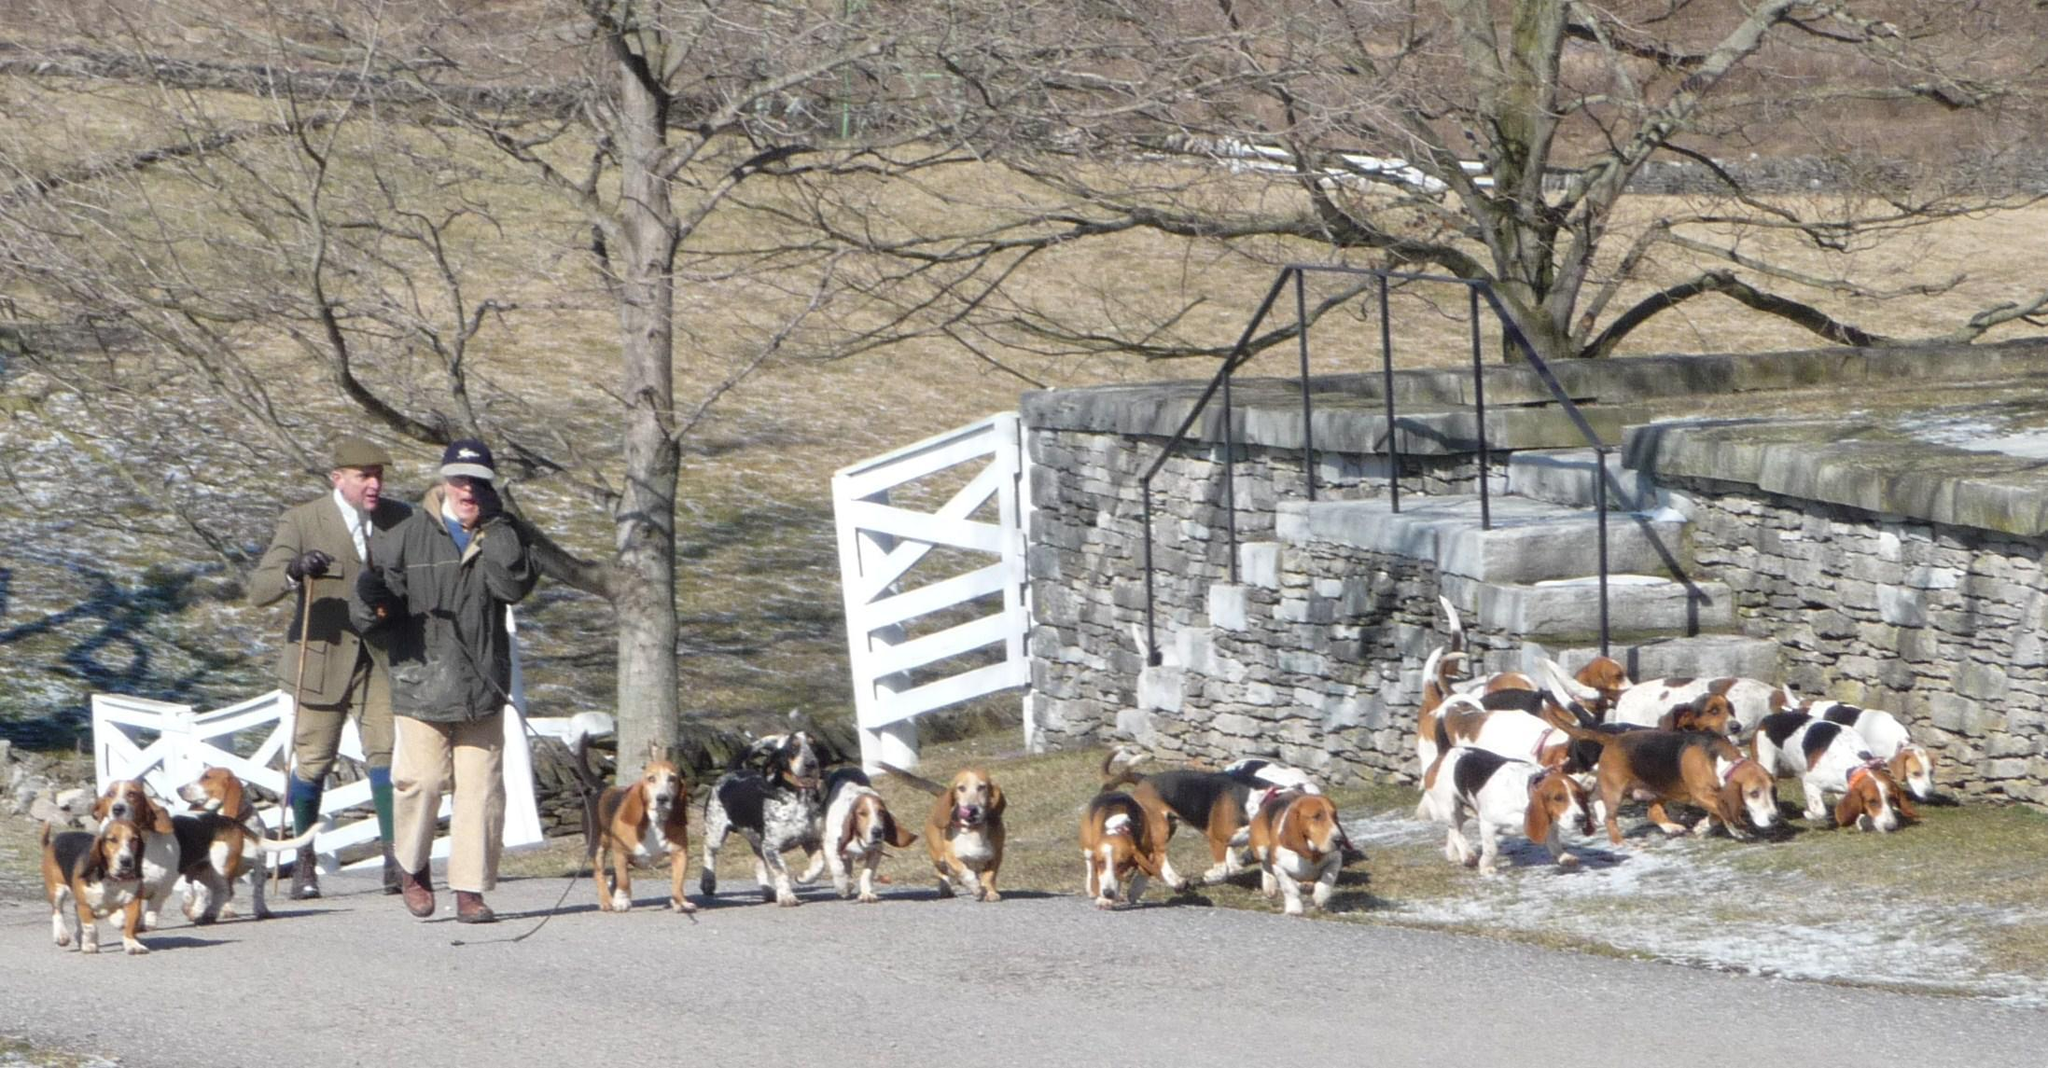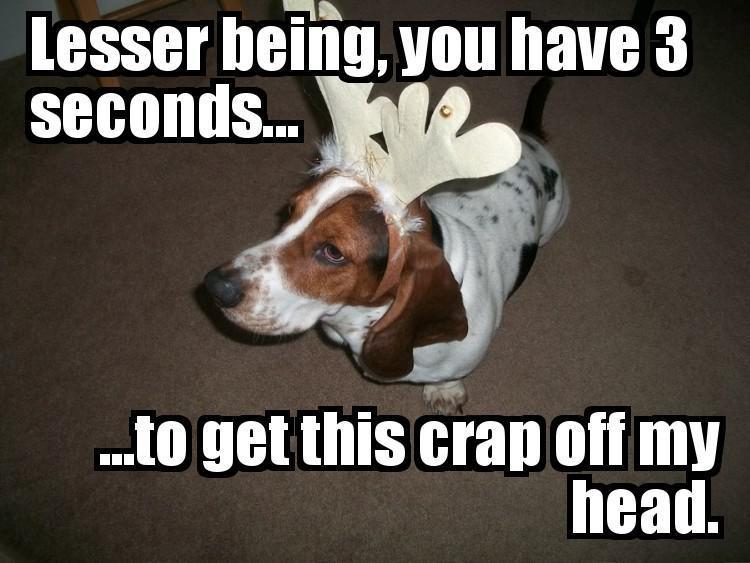The first image is the image on the left, the second image is the image on the right. Assess this claim about the two images: "There are fewer than three people wrangling a pack of dogs.". Correct or not? Answer yes or no. Yes. The first image is the image on the left, the second image is the image on the right. Assess this claim about the two images: "A gentleman wearing a jacket, tie and beanie is walking the dogs down a road in one of the images.". Correct or not? Answer yes or no. Yes. 